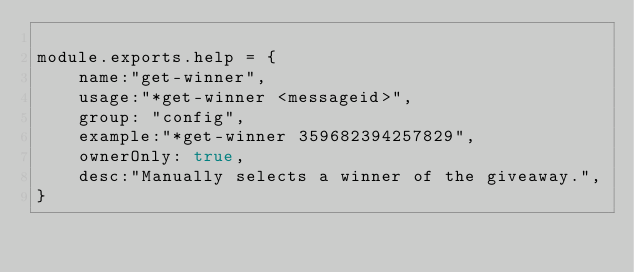<code> <loc_0><loc_0><loc_500><loc_500><_JavaScript_>
module.exports.help = {
    name:"get-winner",
    usage:"*get-winner <messageid>",
    group: "config",
    example:"*get-winner 359682394257829",
    ownerOnly: true,
    desc:"Manually selects a winner of the giveaway.",
} </code> 